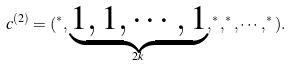<formula> <loc_0><loc_0><loc_500><loc_500>c ^ { ( 2 ) } = ( ^ { * } , \underbrace { 1 , 1 , \cdots , 1 } _ { 2 k } , ^ { * } , ^ { * } , \cdots , ^ { * } ) .</formula> 